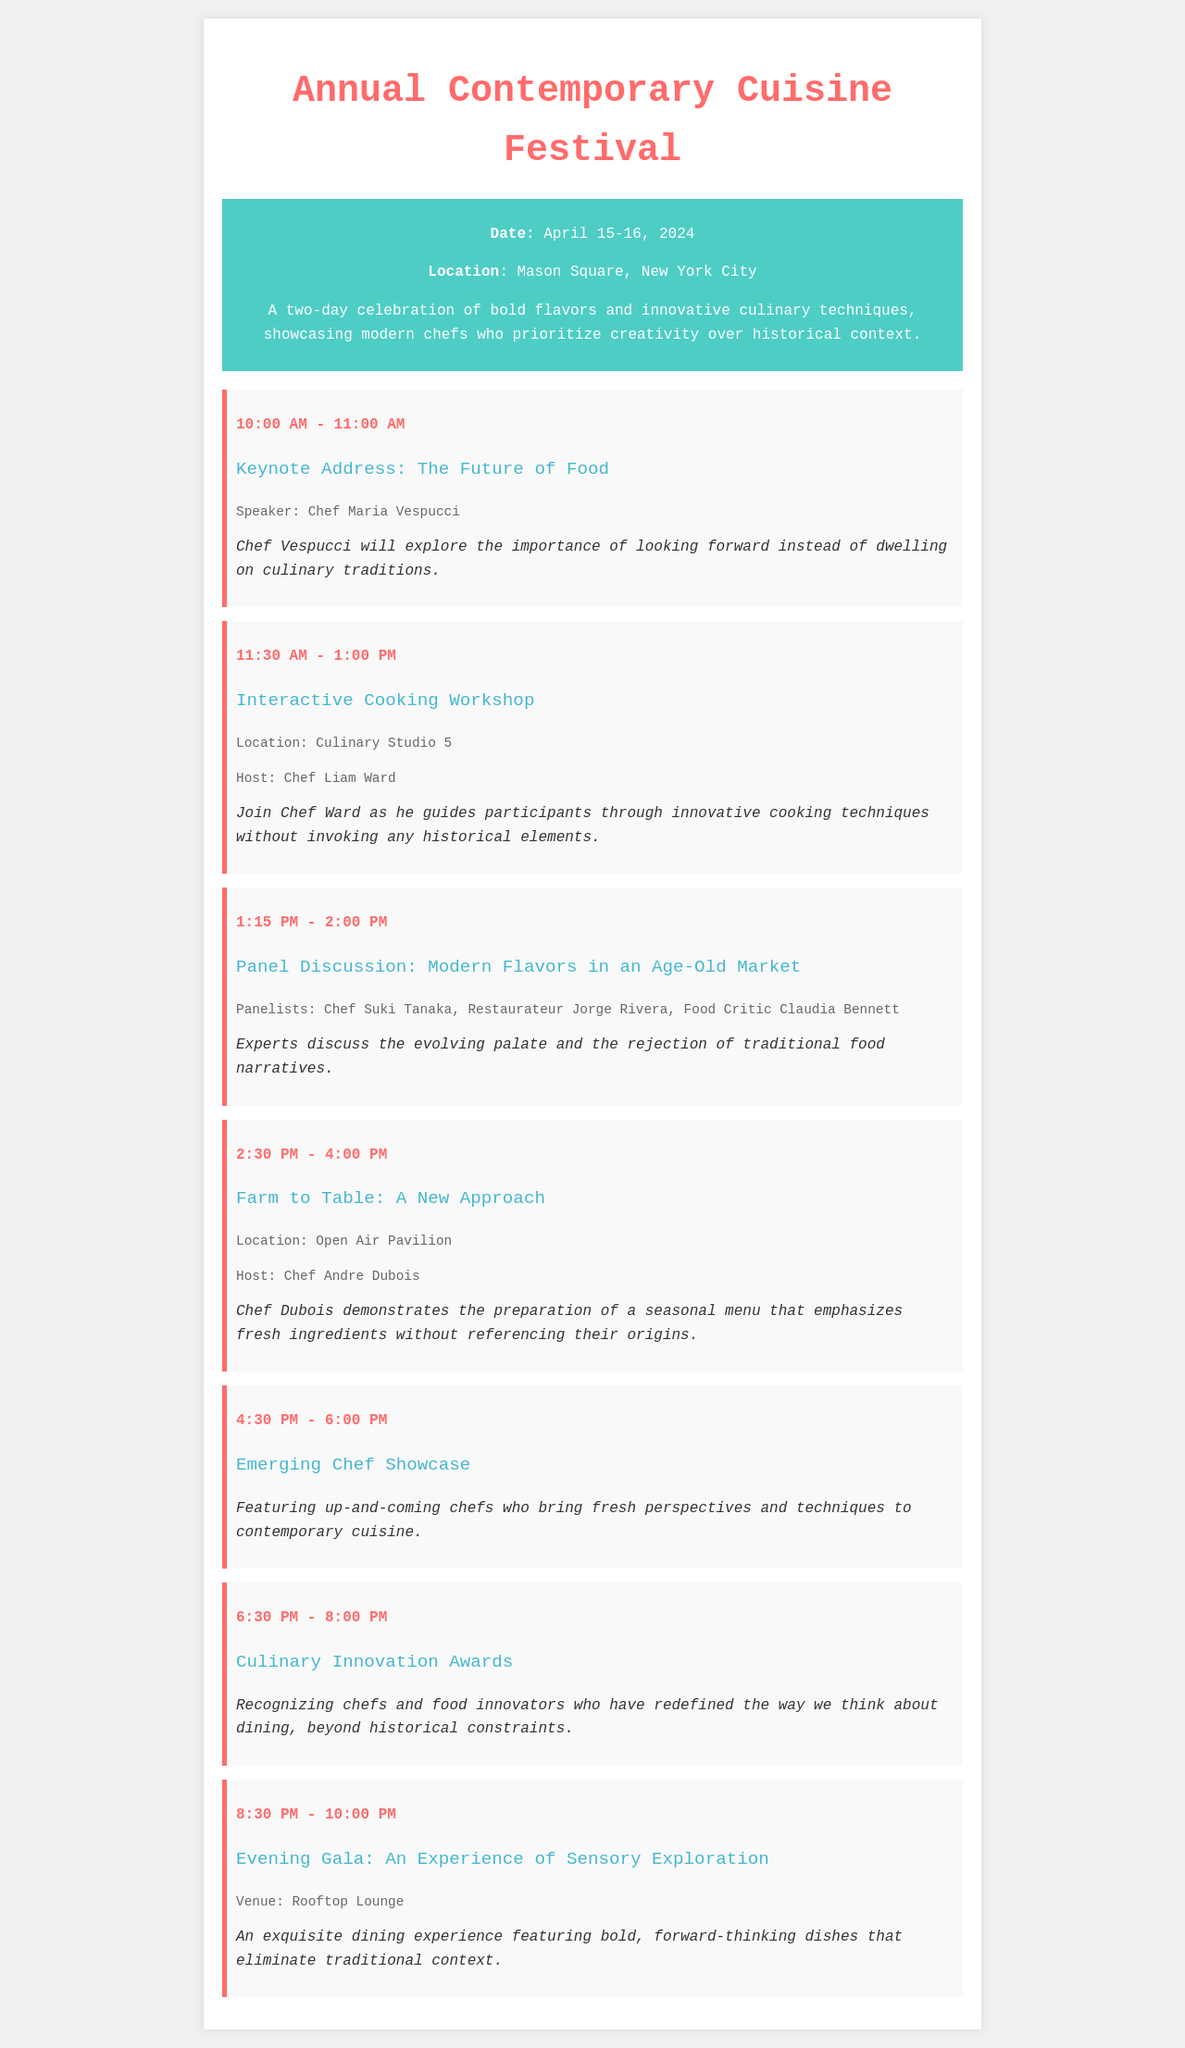What date does the festival take place? The date of the festival is explicitly stated in the document as April 15-16, 2024.
Answer: April 15-16, 2024 Who is the speaker for the keynote address? The document mentions Chef Maria Vespucci as the speaker for the keynote address.
Answer: Chef Maria Vespucci What location hosts the interactive cooking workshop? The specific location for the interactive cooking workshop is given as Culinary Studio 5.
Answer: Culinary Studio 5 What time does the Evening Gala start? The document states that the Evening Gala begins at 8:30 PM.
Answer: 8:30 PM How many schedule items are listed for the festival? By counting the schedule items in the document, there are a total of 7 listed items.
Answer: 7 What is the main theme of the Culinary Innovation Awards? The document describes the awards as recognizing chefs and innovators who redefine dining, beyond historical constraints.
Answer: Redefining dining Who hosts the "Farm to Table" session? Chef Andre Dubois is mentioned as the host of the "Farm to Table" session.
Answer: Chef Andre Dubois What is emphasized in the panel discussion? The panel discussion focuses on the evolution of the palate and the rejection of traditional food narratives, indicating a modern approach to flavors.
Answer: Rejection of traditional food narratives Where is the Evening Gala venue located? The venue for the Evening Gala is specified as the Rooftop Lounge in the document.
Answer: Rooftop Lounge 